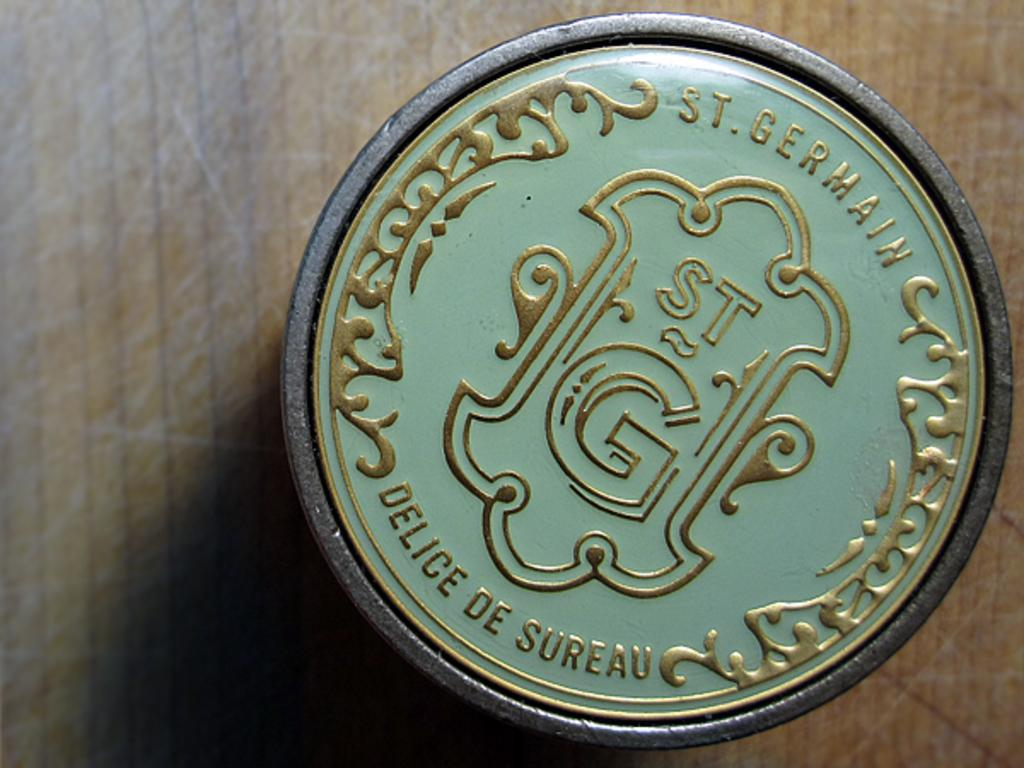<image>
Share a concise interpretation of the image provided. A logo that has the phrase Delice de Sureau written on it. 